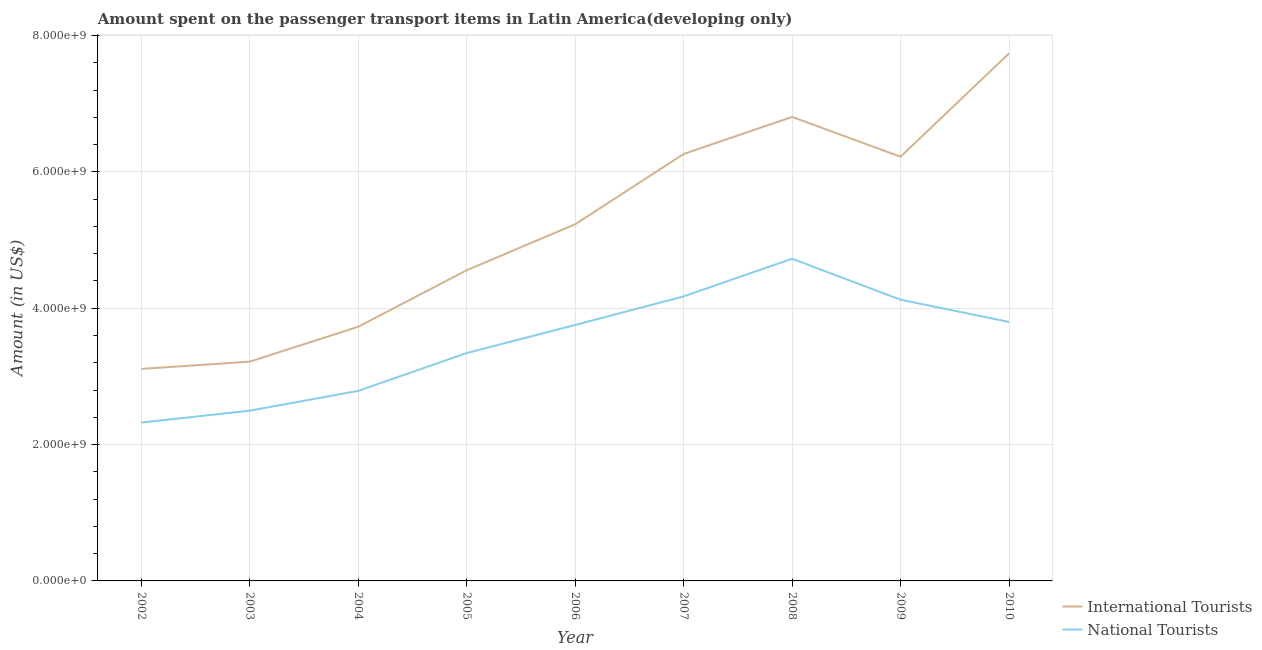What is the amount spent on transport items of national tourists in 2002?
Give a very brief answer. 2.32e+09. Across all years, what is the maximum amount spent on transport items of international tourists?
Your response must be concise. 7.74e+09. Across all years, what is the minimum amount spent on transport items of national tourists?
Offer a terse response. 2.32e+09. What is the total amount spent on transport items of national tourists in the graph?
Keep it short and to the point. 3.15e+1. What is the difference between the amount spent on transport items of international tourists in 2004 and that in 2009?
Offer a terse response. -2.49e+09. What is the difference between the amount spent on transport items of international tourists in 2002 and the amount spent on transport items of national tourists in 2010?
Make the answer very short. -6.89e+08. What is the average amount spent on transport items of international tourists per year?
Give a very brief answer. 5.21e+09. In the year 2004, what is the difference between the amount spent on transport items of international tourists and amount spent on transport items of national tourists?
Provide a succinct answer. 9.41e+08. In how many years, is the amount spent on transport items of national tourists greater than 1200000000 US$?
Provide a succinct answer. 9. What is the ratio of the amount spent on transport items of national tourists in 2005 to that in 2006?
Provide a short and direct response. 0.89. Is the difference between the amount spent on transport items of international tourists in 2006 and 2010 greater than the difference between the amount spent on transport items of national tourists in 2006 and 2010?
Offer a terse response. No. What is the difference between the highest and the second highest amount spent on transport items of international tourists?
Keep it short and to the point. 9.33e+08. What is the difference between the highest and the lowest amount spent on transport items of international tourists?
Provide a succinct answer. 4.63e+09. In how many years, is the amount spent on transport items of national tourists greater than the average amount spent on transport items of national tourists taken over all years?
Offer a very short reply. 5. Is the sum of the amount spent on transport items of international tourists in 2007 and 2009 greater than the maximum amount spent on transport items of national tourists across all years?
Give a very brief answer. Yes. Does the amount spent on transport items of national tourists monotonically increase over the years?
Ensure brevity in your answer.  No. Is the amount spent on transport items of national tourists strictly less than the amount spent on transport items of international tourists over the years?
Make the answer very short. Yes. How many years are there in the graph?
Offer a terse response. 9. Are the values on the major ticks of Y-axis written in scientific E-notation?
Keep it short and to the point. Yes. Does the graph contain any zero values?
Keep it short and to the point. No. Does the graph contain grids?
Offer a terse response. Yes. Where does the legend appear in the graph?
Keep it short and to the point. Bottom right. How many legend labels are there?
Your answer should be compact. 2. How are the legend labels stacked?
Offer a very short reply. Vertical. What is the title of the graph?
Your response must be concise. Amount spent on the passenger transport items in Latin America(developing only). Does "Researchers" appear as one of the legend labels in the graph?
Give a very brief answer. No. What is the label or title of the X-axis?
Your answer should be very brief. Year. What is the label or title of the Y-axis?
Offer a very short reply. Amount (in US$). What is the Amount (in US$) of International Tourists in 2002?
Ensure brevity in your answer.  3.11e+09. What is the Amount (in US$) of National Tourists in 2002?
Keep it short and to the point. 2.32e+09. What is the Amount (in US$) of International Tourists in 2003?
Your answer should be compact. 3.22e+09. What is the Amount (in US$) in National Tourists in 2003?
Keep it short and to the point. 2.50e+09. What is the Amount (in US$) of International Tourists in 2004?
Provide a succinct answer. 3.73e+09. What is the Amount (in US$) in National Tourists in 2004?
Keep it short and to the point. 2.79e+09. What is the Amount (in US$) of International Tourists in 2005?
Offer a very short reply. 4.56e+09. What is the Amount (in US$) of National Tourists in 2005?
Provide a succinct answer. 3.34e+09. What is the Amount (in US$) of International Tourists in 2006?
Offer a very short reply. 5.23e+09. What is the Amount (in US$) of National Tourists in 2006?
Make the answer very short. 3.76e+09. What is the Amount (in US$) of International Tourists in 2007?
Your answer should be compact. 6.26e+09. What is the Amount (in US$) in National Tourists in 2007?
Make the answer very short. 4.17e+09. What is the Amount (in US$) of International Tourists in 2008?
Give a very brief answer. 6.81e+09. What is the Amount (in US$) in National Tourists in 2008?
Offer a terse response. 4.73e+09. What is the Amount (in US$) of International Tourists in 2009?
Your answer should be very brief. 6.22e+09. What is the Amount (in US$) in National Tourists in 2009?
Offer a terse response. 4.13e+09. What is the Amount (in US$) of International Tourists in 2010?
Give a very brief answer. 7.74e+09. What is the Amount (in US$) of National Tourists in 2010?
Offer a very short reply. 3.80e+09. Across all years, what is the maximum Amount (in US$) in International Tourists?
Keep it short and to the point. 7.74e+09. Across all years, what is the maximum Amount (in US$) of National Tourists?
Your response must be concise. 4.73e+09. Across all years, what is the minimum Amount (in US$) in International Tourists?
Offer a very short reply. 3.11e+09. Across all years, what is the minimum Amount (in US$) in National Tourists?
Offer a very short reply. 2.32e+09. What is the total Amount (in US$) of International Tourists in the graph?
Make the answer very short. 4.69e+1. What is the total Amount (in US$) of National Tourists in the graph?
Make the answer very short. 3.15e+1. What is the difference between the Amount (in US$) of International Tourists in 2002 and that in 2003?
Provide a succinct answer. -1.06e+08. What is the difference between the Amount (in US$) of National Tourists in 2002 and that in 2003?
Your response must be concise. -1.75e+08. What is the difference between the Amount (in US$) in International Tourists in 2002 and that in 2004?
Offer a terse response. -6.18e+08. What is the difference between the Amount (in US$) of National Tourists in 2002 and that in 2004?
Provide a short and direct response. -4.65e+08. What is the difference between the Amount (in US$) of International Tourists in 2002 and that in 2005?
Offer a terse response. -1.45e+09. What is the difference between the Amount (in US$) of National Tourists in 2002 and that in 2005?
Give a very brief answer. -1.02e+09. What is the difference between the Amount (in US$) of International Tourists in 2002 and that in 2006?
Keep it short and to the point. -2.12e+09. What is the difference between the Amount (in US$) in National Tourists in 2002 and that in 2006?
Make the answer very short. -1.43e+09. What is the difference between the Amount (in US$) in International Tourists in 2002 and that in 2007?
Give a very brief answer. -3.15e+09. What is the difference between the Amount (in US$) of National Tourists in 2002 and that in 2007?
Ensure brevity in your answer.  -1.85e+09. What is the difference between the Amount (in US$) of International Tourists in 2002 and that in 2008?
Provide a short and direct response. -3.70e+09. What is the difference between the Amount (in US$) of National Tourists in 2002 and that in 2008?
Your answer should be very brief. -2.40e+09. What is the difference between the Amount (in US$) of International Tourists in 2002 and that in 2009?
Your response must be concise. -3.11e+09. What is the difference between the Amount (in US$) in National Tourists in 2002 and that in 2009?
Your answer should be compact. -1.80e+09. What is the difference between the Amount (in US$) in International Tourists in 2002 and that in 2010?
Your answer should be very brief. -4.63e+09. What is the difference between the Amount (in US$) of National Tourists in 2002 and that in 2010?
Keep it short and to the point. -1.48e+09. What is the difference between the Amount (in US$) of International Tourists in 2003 and that in 2004?
Offer a very short reply. -5.12e+08. What is the difference between the Amount (in US$) of National Tourists in 2003 and that in 2004?
Give a very brief answer. -2.90e+08. What is the difference between the Amount (in US$) in International Tourists in 2003 and that in 2005?
Give a very brief answer. -1.34e+09. What is the difference between the Amount (in US$) of National Tourists in 2003 and that in 2005?
Make the answer very short. -8.45e+08. What is the difference between the Amount (in US$) in International Tourists in 2003 and that in 2006?
Give a very brief answer. -2.02e+09. What is the difference between the Amount (in US$) in National Tourists in 2003 and that in 2006?
Your response must be concise. -1.26e+09. What is the difference between the Amount (in US$) of International Tourists in 2003 and that in 2007?
Your answer should be compact. -3.05e+09. What is the difference between the Amount (in US$) of National Tourists in 2003 and that in 2007?
Ensure brevity in your answer.  -1.68e+09. What is the difference between the Amount (in US$) of International Tourists in 2003 and that in 2008?
Your answer should be compact. -3.59e+09. What is the difference between the Amount (in US$) in National Tourists in 2003 and that in 2008?
Keep it short and to the point. -2.23e+09. What is the difference between the Amount (in US$) in International Tourists in 2003 and that in 2009?
Your answer should be compact. -3.01e+09. What is the difference between the Amount (in US$) in National Tourists in 2003 and that in 2009?
Offer a very short reply. -1.63e+09. What is the difference between the Amount (in US$) in International Tourists in 2003 and that in 2010?
Your response must be concise. -4.52e+09. What is the difference between the Amount (in US$) in National Tourists in 2003 and that in 2010?
Your answer should be compact. -1.30e+09. What is the difference between the Amount (in US$) of International Tourists in 2004 and that in 2005?
Provide a short and direct response. -8.29e+08. What is the difference between the Amount (in US$) of National Tourists in 2004 and that in 2005?
Provide a short and direct response. -5.55e+08. What is the difference between the Amount (in US$) in International Tourists in 2004 and that in 2006?
Offer a terse response. -1.50e+09. What is the difference between the Amount (in US$) of National Tourists in 2004 and that in 2006?
Your answer should be very brief. -9.67e+08. What is the difference between the Amount (in US$) in International Tourists in 2004 and that in 2007?
Your answer should be very brief. -2.53e+09. What is the difference between the Amount (in US$) of National Tourists in 2004 and that in 2007?
Your response must be concise. -1.39e+09. What is the difference between the Amount (in US$) in International Tourists in 2004 and that in 2008?
Give a very brief answer. -3.08e+09. What is the difference between the Amount (in US$) in National Tourists in 2004 and that in 2008?
Your answer should be very brief. -1.94e+09. What is the difference between the Amount (in US$) of International Tourists in 2004 and that in 2009?
Your answer should be compact. -2.49e+09. What is the difference between the Amount (in US$) in National Tourists in 2004 and that in 2009?
Your answer should be compact. -1.34e+09. What is the difference between the Amount (in US$) of International Tourists in 2004 and that in 2010?
Your response must be concise. -4.01e+09. What is the difference between the Amount (in US$) of National Tourists in 2004 and that in 2010?
Make the answer very short. -1.01e+09. What is the difference between the Amount (in US$) in International Tourists in 2005 and that in 2006?
Your response must be concise. -6.74e+08. What is the difference between the Amount (in US$) in National Tourists in 2005 and that in 2006?
Provide a succinct answer. -4.12e+08. What is the difference between the Amount (in US$) of International Tourists in 2005 and that in 2007?
Provide a short and direct response. -1.71e+09. What is the difference between the Amount (in US$) in National Tourists in 2005 and that in 2007?
Your answer should be compact. -8.31e+08. What is the difference between the Amount (in US$) of International Tourists in 2005 and that in 2008?
Keep it short and to the point. -2.25e+09. What is the difference between the Amount (in US$) of National Tourists in 2005 and that in 2008?
Keep it short and to the point. -1.38e+09. What is the difference between the Amount (in US$) of International Tourists in 2005 and that in 2009?
Give a very brief answer. -1.67e+09. What is the difference between the Amount (in US$) of National Tourists in 2005 and that in 2009?
Give a very brief answer. -7.82e+08. What is the difference between the Amount (in US$) in International Tourists in 2005 and that in 2010?
Give a very brief answer. -3.18e+09. What is the difference between the Amount (in US$) in National Tourists in 2005 and that in 2010?
Your answer should be very brief. -4.56e+08. What is the difference between the Amount (in US$) of International Tourists in 2006 and that in 2007?
Offer a terse response. -1.03e+09. What is the difference between the Amount (in US$) of National Tourists in 2006 and that in 2007?
Offer a terse response. -4.19e+08. What is the difference between the Amount (in US$) in International Tourists in 2006 and that in 2008?
Your answer should be very brief. -1.58e+09. What is the difference between the Amount (in US$) in National Tourists in 2006 and that in 2008?
Your answer should be compact. -9.71e+08. What is the difference between the Amount (in US$) in International Tourists in 2006 and that in 2009?
Your response must be concise. -9.91e+08. What is the difference between the Amount (in US$) of National Tourists in 2006 and that in 2009?
Keep it short and to the point. -3.70e+08. What is the difference between the Amount (in US$) in International Tourists in 2006 and that in 2010?
Your answer should be very brief. -2.51e+09. What is the difference between the Amount (in US$) of National Tourists in 2006 and that in 2010?
Ensure brevity in your answer.  -4.44e+07. What is the difference between the Amount (in US$) of International Tourists in 2007 and that in 2008?
Your response must be concise. -5.44e+08. What is the difference between the Amount (in US$) of National Tourists in 2007 and that in 2008?
Ensure brevity in your answer.  -5.52e+08. What is the difference between the Amount (in US$) of International Tourists in 2007 and that in 2009?
Provide a short and direct response. 3.99e+07. What is the difference between the Amount (in US$) in National Tourists in 2007 and that in 2009?
Your answer should be compact. 4.91e+07. What is the difference between the Amount (in US$) of International Tourists in 2007 and that in 2010?
Provide a succinct answer. -1.48e+09. What is the difference between the Amount (in US$) in National Tourists in 2007 and that in 2010?
Ensure brevity in your answer.  3.75e+08. What is the difference between the Amount (in US$) in International Tourists in 2008 and that in 2009?
Your answer should be compact. 5.84e+08. What is the difference between the Amount (in US$) in National Tourists in 2008 and that in 2009?
Make the answer very short. 6.01e+08. What is the difference between the Amount (in US$) in International Tourists in 2008 and that in 2010?
Keep it short and to the point. -9.33e+08. What is the difference between the Amount (in US$) in National Tourists in 2008 and that in 2010?
Keep it short and to the point. 9.27e+08. What is the difference between the Amount (in US$) in International Tourists in 2009 and that in 2010?
Provide a short and direct response. -1.52e+09. What is the difference between the Amount (in US$) of National Tourists in 2009 and that in 2010?
Provide a short and direct response. 3.26e+08. What is the difference between the Amount (in US$) in International Tourists in 2002 and the Amount (in US$) in National Tourists in 2003?
Your answer should be compact. 6.13e+08. What is the difference between the Amount (in US$) of International Tourists in 2002 and the Amount (in US$) of National Tourists in 2004?
Keep it short and to the point. 3.22e+08. What is the difference between the Amount (in US$) in International Tourists in 2002 and the Amount (in US$) in National Tourists in 2005?
Give a very brief answer. -2.33e+08. What is the difference between the Amount (in US$) in International Tourists in 2002 and the Amount (in US$) in National Tourists in 2006?
Provide a short and direct response. -6.45e+08. What is the difference between the Amount (in US$) of International Tourists in 2002 and the Amount (in US$) of National Tourists in 2007?
Offer a terse response. -1.06e+09. What is the difference between the Amount (in US$) in International Tourists in 2002 and the Amount (in US$) in National Tourists in 2008?
Your response must be concise. -1.62e+09. What is the difference between the Amount (in US$) of International Tourists in 2002 and the Amount (in US$) of National Tourists in 2009?
Ensure brevity in your answer.  -1.02e+09. What is the difference between the Amount (in US$) in International Tourists in 2002 and the Amount (in US$) in National Tourists in 2010?
Ensure brevity in your answer.  -6.89e+08. What is the difference between the Amount (in US$) of International Tourists in 2003 and the Amount (in US$) of National Tourists in 2004?
Offer a terse response. 4.29e+08. What is the difference between the Amount (in US$) of International Tourists in 2003 and the Amount (in US$) of National Tourists in 2005?
Make the answer very short. -1.26e+08. What is the difference between the Amount (in US$) of International Tourists in 2003 and the Amount (in US$) of National Tourists in 2006?
Offer a terse response. -5.38e+08. What is the difference between the Amount (in US$) in International Tourists in 2003 and the Amount (in US$) in National Tourists in 2007?
Your response must be concise. -9.58e+08. What is the difference between the Amount (in US$) in International Tourists in 2003 and the Amount (in US$) in National Tourists in 2008?
Provide a short and direct response. -1.51e+09. What is the difference between the Amount (in US$) of International Tourists in 2003 and the Amount (in US$) of National Tourists in 2009?
Your answer should be compact. -9.09e+08. What is the difference between the Amount (in US$) in International Tourists in 2003 and the Amount (in US$) in National Tourists in 2010?
Make the answer very short. -5.83e+08. What is the difference between the Amount (in US$) in International Tourists in 2004 and the Amount (in US$) in National Tourists in 2005?
Your answer should be compact. 3.86e+08. What is the difference between the Amount (in US$) in International Tourists in 2004 and the Amount (in US$) in National Tourists in 2006?
Offer a very short reply. -2.64e+07. What is the difference between the Amount (in US$) in International Tourists in 2004 and the Amount (in US$) in National Tourists in 2007?
Your answer should be very brief. -4.46e+08. What is the difference between the Amount (in US$) of International Tourists in 2004 and the Amount (in US$) of National Tourists in 2008?
Your response must be concise. -9.98e+08. What is the difference between the Amount (in US$) in International Tourists in 2004 and the Amount (in US$) in National Tourists in 2009?
Make the answer very short. -3.97e+08. What is the difference between the Amount (in US$) of International Tourists in 2004 and the Amount (in US$) of National Tourists in 2010?
Provide a succinct answer. -7.08e+07. What is the difference between the Amount (in US$) in International Tourists in 2005 and the Amount (in US$) in National Tourists in 2006?
Ensure brevity in your answer.  8.03e+08. What is the difference between the Amount (in US$) in International Tourists in 2005 and the Amount (in US$) in National Tourists in 2007?
Make the answer very short. 3.84e+08. What is the difference between the Amount (in US$) of International Tourists in 2005 and the Amount (in US$) of National Tourists in 2008?
Your answer should be compact. -1.68e+08. What is the difference between the Amount (in US$) in International Tourists in 2005 and the Amount (in US$) in National Tourists in 2009?
Make the answer very short. 4.33e+08. What is the difference between the Amount (in US$) in International Tourists in 2005 and the Amount (in US$) in National Tourists in 2010?
Keep it short and to the point. 7.59e+08. What is the difference between the Amount (in US$) in International Tourists in 2006 and the Amount (in US$) in National Tourists in 2007?
Ensure brevity in your answer.  1.06e+09. What is the difference between the Amount (in US$) in International Tourists in 2006 and the Amount (in US$) in National Tourists in 2008?
Offer a terse response. 5.05e+08. What is the difference between the Amount (in US$) of International Tourists in 2006 and the Amount (in US$) of National Tourists in 2009?
Your response must be concise. 1.11e+09. What is the difference between the Amount (in US$) of International Tourists in 2006 and the Amount (in US$) of National Tourists in 2010?
Give a very brief answer. 1.43e+09. What is the difference between the Amount (in US$) of International Tourists in 2007 and the Amount (in US$) of National Tourists in 2008?
Your answer should be compact. 1.54e+09. What is the difference between the Amount (in US$) in International Tourists in 2007 and the Amount (in US$) in National Tourists in 2009?
Make the answer very short. 2.14e+09. What is the difference between the Amount (in US$) in International Tourists in 2007 and the Amount (in US$) in National Tourists in 2010?
Provide a short and direct response. 2.46e+09. What is the difference between the Amount (in US$) of International Tourists in 2008 and the Amount (in US$) of National Tourists in 2009?
Give a very brief answer. 2.68e+09. What is the difference between the Amount (in US$) in International Tourists in 2008 and the Amount (in US$) in National Tourists in 2010?
Provide a short and direct response. 3.01e+09. What is the difference between the Amount (in US$) of International Tourists in 2009 and the Amount (in US$) of National Tourists in 2010?
Your response must be concise. 2.42e+09. What is the average Amount (in US$) of International Tourists per year?
Offer a very short reply. 5.21e+09. What is the average Amount (in US$) in National Tourists per year?
Your answer should be compact. 3.50e+09. In the year 2002, what is the difference between the Amount (in US$) of International Tourists and Amount (in US$) of National Tourists?
Keep it short and to the point. 7.87e+08. In the year 2003, what is the difference between the Amount (in US$) in International Tourists and Amount (in US$) in National Tourists?
Your answer should be very brief. 7.19e+08. In the year 2004, what is the difference between the Amount (in US$) in International Tourists and Amount (in US$) in National Tourists?
Make the answer very short. 9.41e+08. In the year 2005, what is the difference between the Amount (in US$) in International Tourists and Amount (in US$) in National Tourists?
Provide a succinct answer. 1.22e+09. In the year 2006, what is the difference between the Amount (in US$) of International Tourists and Amount (in US$) of National Tourists?
Offer a very short reply. 1.48e+09. In the year 2007, what is the difference between the Amount (in US$) in International Tourists and Amount (in US$) in National Tourists?
Offer a very short reply. 2.09e+09. In the year 2008, what is the difference between the Amount (in US$) of International Tourists and Amount (in US$) of National Tourists?
Make the answer very short. 2.08e+09. In the year 2009, what is the difference between the Amount (in US$) of International Tourists and Amount (in US$) of National Tourists?
Offer a terse response. 2.10e+09. In the year 2010, what is the difference between the Amount (in US$) in International Tourists and Amount (in US$) in National Tourists?
Offer a very short reply. 3.94e+09. What is the ratio of the Amount (in US$) of International Tourists in 2002 to that in 2003?
Ensure brevity in your answer.  0.97. What is the ratio of the Amount (in US$) in International Tourists in 2002 to that in 2004?
Your answer should be very brief. 0.83. What is the ratio of the Amount (in US$) in National Tourists in 2002 to that in 2004?
Keep it short and to the point. 0.83. What is the ratio of the Amount (in US$) in International Tourists in 2002 to that in 2005?
Make the answer very short. 0.68. What is the ratio of the Amount (in US$) of National Tourists in 2002 to that in 2005?
Offer a very short reply. 0.69. What is the ratio of the Amount (in US$) of International Tourists in 2002 to that in 2006?
Provide a succinct answer. 0.59. What is the ratio of the Amount (in US$) in National Tourists in 2002 to that in 2006?
Offer a terse response. 0.62. What is the ratio of the Amount (in US$) in International Tourists in 2002 to that in 2007?
Give a very brief answer. 0.5. What is the ratio of the Amount (in US$) in National Tourists in 2002 to that in 2007?
Provide a succinct answer. 0.56. What is the ratio of the Amount (in US$) of International Tourists in 2002 to that in 2008?
Offer a very short reply. 0.46. What is the ratio of the Amount (in US$) of National Tourists in 2002 to that in 2008?
Give a very brief answer. 0.49. What is the ratio of the Amount (in US$) in International Tourists in 2002 to that in 2009?
Give a very brief answer. 0.5. What is the ratio of the Amount (in US$) of National Tourists in 2002 to that in 2009?
Ensure brevity in your answer.  0.56. What is the ratio of the Amount (in US$) of International Tourists in 2002 to that in 2010?
Your response must be concise. 0.4. What is the ratio of the Amount (in US$) of National Tourists in 2002 to that in 2010?
Offer a terse response. 0.61. What is the ratio of the Amount (in US$) of International Tourists in 2003 to that in 2004?
Make the answer very short. 0.86. What is the ratio of the Amount (in US$) of National Tourists in 2003 to that in 2004?
Keep it short and to the point. 0.9. What is the ratio of the Amount (in US$) of International Tourists in 2003 to that in 2005?
Your response must be concise. 0.71. What is the ratio of the Amount (in US$) in National Tourists in 2003 to that in 2005?
Your answer should be compact. 0.75. What is the ratio of the Amount (in US$) of International Tourists in 2003 to that in 2006?
Your answer should be very brief. 0.61. What is the ratio of the Amount (in US$) in National Tourists in 2003 to that in 2006?
Your answer should be compact. 0.67. What is the ratio of the Amount (in US$) of International Tourists in 2003 to that in 2007?
Offer a terse response. 0.51. What is the ratio of the Amount (in US$) in National Tourists in 2003 to that in 2007?
Make the answer very short. 0.6. What is the ratio of the Amount (in US$) in International Tourists in 2003 to that in 2008?
Offer a very short reply. 0.47. What is the ratio of the Amount (in US$) of National Tourists in 2003 to that in 2008?
Offer a terse response. 0.53. What is the ratio of the Amount (in US$) of International Tourists in 2003 to that in 2009?
Keep it short and to the point. 0.52. What is the ratio of the Amount (in US$) in National Tourists in 2003 to that in 2009?
Your response must be concise. 0.61. What is the ratio of the Amount (in US$) of International Tourists in 2003 to that in 2010?
Your answer should be compact. 0.42. What is the ratio of the Amount (in US$) of National Tourists in 2003 to that in 2010?
Make the answer very short. 0.66. What is the ratio of the Amount (in US$) in International Tourists in 2004 to that in 2005?
Make the answer very short. 0.82. What is the ratio of the Amount (in US$) in National Tourists in 2004 to that in 2005?
Make the answer very short. 0.83. What is the ratio of the Amount (in US$) in International Tourists in 2004 to that in 2006?
Your answer should be compact. 0.71. What is the ratio of the Amount (in US$) of National Tourists in 2004 to that in 2006?
Provide a short and direct response. 0.74. What is the ratio of the Amount (in US$) of International Tourists in 2004 to that in 2007?
Offer a terse response. 0.6. What is the ratio of the Amount (in US$) of National Tourists in 2004 to that in 2007?
Make the answer very short. 0.67. What is the ratio of the Amount (in US$) of International Tourists in 2004 to that in 2008?
Provide a succinct answer. 0.55. What is the ratio of the Amount (in US$) in National Tourists in 2004 to that in 2008?
Your answer should be very brief. 0.59. What is the ratio of the Amount (in US$) of International Tourists in 2004 to that in 2009?
Provide a succinct answer. 0.6. What is the ratio of the Amount (in US$) in National Tourists in 2004 to that in 2009?
Give a very brief answer. 0.68. What is the ratio of the Amount (in US$) in International Tourists in 2004 to that in 2010?
Your answer should be compact. 0.48. What is the ratio of the Amount (in US$) in National Tourists in 2004 to that in 2010?
Offer a terse response. 0.73. What is the ratio of the Amount (in US$) of International Tourists in 2005 to that in 2006?
Your response must be concise. 0.87. What is the ratio of the Amount (in US$) of National Tourists in 2005 to that in 2006?
Your answer should be very brief. 0.89. What is the ratio of the Amount (in US$) of International Tourists in 2005 to that in 2007?
Keep it short and to the point. 0.73. What is the ratio of the Amount (in US$) of National Tourists in 2005 to that in 2007?
Your response must be concise. 0.8. What is the ratio of the Amount (in US$) of International Tourists in 2005 to that in 2008?
Provide a succinct answer. 0.67. What is the ratio of the Amount (in US$) in National Tourists in 2005 to that in 2008?
Give a very brief answer. 0.71. What is the ratio of the Amount (in US$) in International Tourists in 2005 to that in 2009?
Give a very brief answer. 0.73. What is the ratio of the Amount (in US$) of National Tourists in 2005 to that in 2009?
Your answer should be compact. 0.81. What is the ratio of the Amount (in US$) in International Tourists in 2005 to that in 2010?
Provide a short and direct response. 0.59. What is the ratio of the Amount (in US$) of National Tourists in 2005 to that in 2010?
Make the answer very short. 0.88. What is the ratio of the Amount (in US$) in International Tourists in 2006 to that in 2007?
Offer a very short reply. 0.84. What is the ratio of the Amount (in US$) in National Tourists in 2006 to that in 2007?
Provide a succinct answer. 0.9. What is the ratio of the Amount (in US$) in International Tourists in 2006 to that in 2008?
Provide a succinct answer. 0.77. What is the ratio of the Amount (in US$) in National Tourists in 2006 to that in 2008?
Offer a terse response. 0.79. What is the ratio of the Amount (in US$) in International Tourists in 2006 to that in 2009?
Ensure brevity in your answer.  0.84. What is the ratio of the Amount (in US$) in National Tourists in 2006 to that in 2009?
Your response must be concise. 0.91. What is the ratio of the Amount (in US$) of International Tourists in 2006 to that in 2010?
Your answer should be compact. 0.68. What is the ratio of the Amount (in US$) in National Tourists in 2006 to that in 2010?
Your response must be concise. 0.99. What is the ratio of the Amount (in US$) in International Tourists in 2007 to that in 2008?
Your response must be concise. 0.92. What is the ratio of the Amount (in US$) of National Tourists in 2007 to that in 2008?
Give a very brief answer. 0.88. What is the ratio of the Amount (in US$) in International Tourists in 2007 to that in 2009?
Offer a very short reply. 1.01. What is the ratio of the Amount (in US$) of National Tourists in 2007 to that in 2009?
Your answer should be compact. 1.01. What is the ratio of the Amount (in US$) of International Tourists in 2007 to that in 2010?
Your answer should be very brief. 0.81. What is the ratio of the Amount (in US$) of National Tourists in 2007 to that in 2010?
Ensure brevity in your answer.  1.1. What is the ratio of the Amount (in US$) of International Tourists in 2008 to that in 2009?
Keep it short and to the point. 1.09. What is the ratio of the Amount (in US$) in National Tourists in 2008 to that in 2009?
Provide a short and direct response. 1.15. What is the ratio of the Amount (in US$) in International Tourists in 2008 to that in 2010?
Ensure brevity in your answer.  0.88. What is the ratio of the Amount (in US$) of National Tourists in 2008 to that in 2010?
Provide a short and direct response. 1.24. What is the ratio of the Amount (in US$) in International Tourists in 2009 to that in 2010?
Give a very brief answer. 0.8. What is the ratio of the Amount (in US$) of National Tourists in 2009 to that in 2010?
Give a very brief answer. 1.09. What is the difference between the highest and the second highest Amount (in US$) in International Tourists?
Your answer should be compact. 9.33e+08. What is the difference between the highest and the second highest Amount (in US$) in National Tourists?
Keep it short and to the point. 5.52e+08. What is the difference between the highest and the lowest Amount (in US$) in International Tourists?
Provide a succinct answer. 4.63e+09. What is the difference between the highest and the lowest Amount (in US$) in National Tourists?
Make the answer very short. 2.40e+09. 